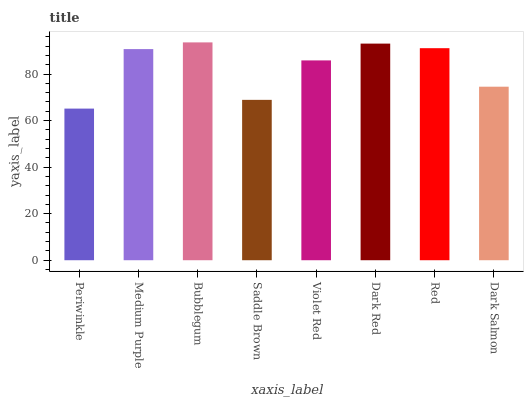Is Periwinkle the minimum?
Answer yes or no. Yes. Is Bubblegum the maximum?
Answer yes or no. Yes. Is Medium Purple the minimum?
Answer yes or no. No. Is Medium Purple the maximum?
Answer yes or no. No. Is Medium Purple greater than Periwinkle?
Answer yes or no. Yes. Is Periwinkle less than Medium Purple?
Answer yes or no. Yes. Is Periwinkle greater than Medium Purple?
Answer yes or no. No. Is Medium Purple less than Periwinkle?
Answer yes or no. No. Is Medium Purple the high median?
Answer yes or no. Yes. Is Violet Red the low median?
Answer yes or no. Yes. Is Dark Red the high median?
Answer yes or no. No. Is Periwinkle the low median?
Answer yes or no. No. 